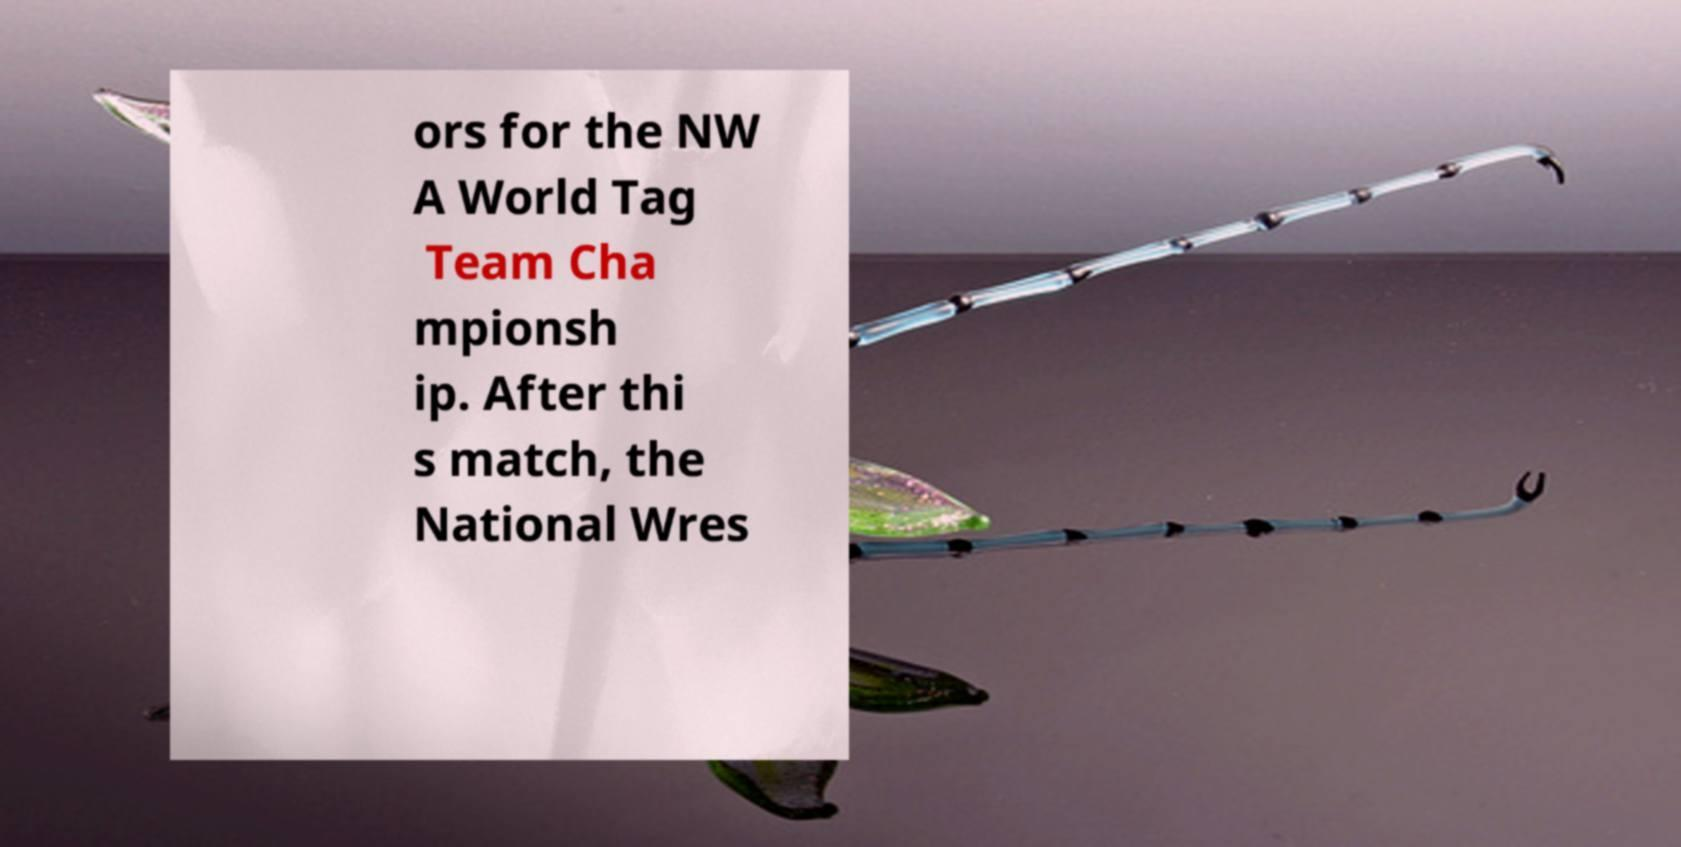For documentation purposes, I need the text within this image transcribed. Could you provide that? ors for the NW A World Tag Team Cha mpionsh ip. After thi s match, the National Wres 